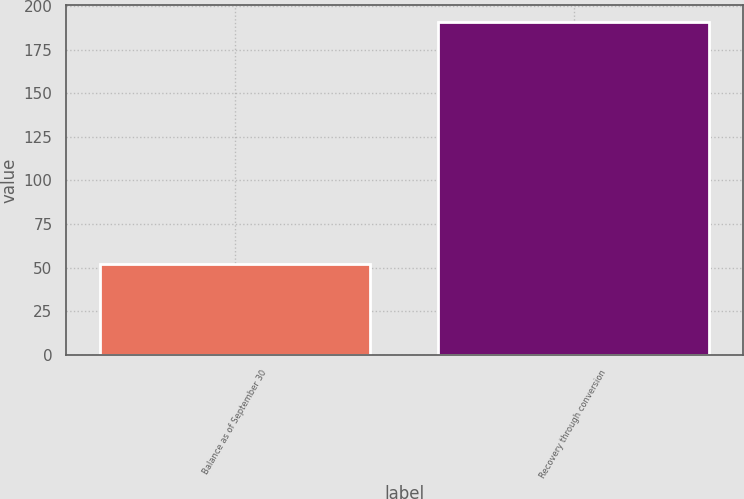<chart> <loc_0><loc_0><loc_500><loc_500><bar_chart><fcel>Balance as of September 30<fcel>Recovery through conversion<nl><fcel>52<fcel>191<nl></chart> 